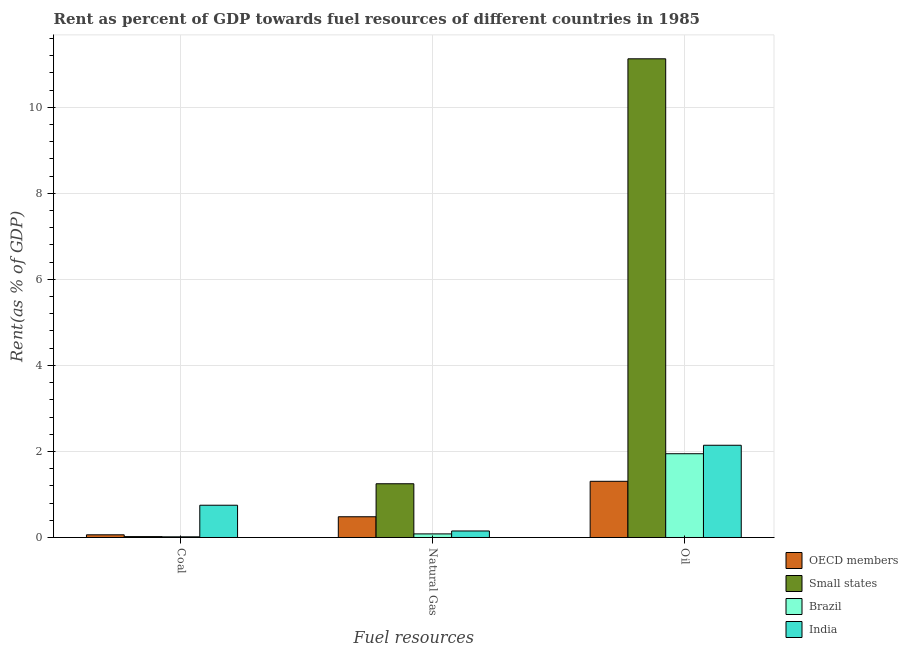How many different coloured bars are there?
Provide a succinct answer. 4. How many groups of bars are there?
Make the answer very short. 3. Are the number of bars per tick equal to the number of legend labels?
Keep it short and to the point. Yes. How many bars are there on the 2nd tick from the right?
Make the answer very short. 4. What is the label of the 1st group of bars from the left?
Ensure brevity in your answer.  Coal. What is the rent towards oil in Small states?
Provide a succinct answer. 11.13. Across all countries, what is the maximum rent towards natural gas?
Offer a terse response. 1.25. Across all countries, what is the minimum rent towards natural gas?
Ensure brevity in your answer.  0.08. In which country was the rent towards natural gas maximum?
Keep it short and to the point. Small states. What is the total rent towards natural gas in the graph?
Provide a short and direct response. 1.97. What is the difference between the rent towards oil in Brazil and that in OECD members?
Ensure brevity in your answer.  0.64. What is the difference between the rent towards coal in Brazil and the rent towards natural gas in OECD members?
Provide a short and direct response. -0.47. What is the average rent towards coal per country?
Ensure brevity in your answer.  0.21. What is the difference between the rent towards coal and rent towards natural gas in India?
Keep it short and to the point. 0.6. What is the ratio of the rent towards natural gas in OECD members to that in Brazil?
Make the answer very short. 5.79. Is the rent towards coal in Small states less than that in Brazil?
Your response must be concise. No. What is the difference between the highest and the second highest rent towards natural gas?
Offer a terse response. 0.77. What is the difference between the highest and the lowest rent towards coal?
Ensure brevity in your answer.  0.73. In how many countries, is the rent towards coal greater than the average rent towards coal taken over all countries?
Offer a terse response. 1. Is the sum of the rent towards natural gas in Small states and Brazil greater than the maximum rent towards coal across all countries?
Your answer should be compact. Yes. What does the 3rd bar from the left in Natural Gas represents?
Provide a succinct answer. Brazil. What does the 3rd bar from the right in Coal represents?
Ensure brevity in your answer.  Small states. Are all the bars in the graph horizontal?
Keep it short and to the point. No. How many countries are there in the graph?
Keep it short and to the point. 4. Are the values on the major ticks of Y-axis written in scientific E-notation?
Your response must be concise. No. Does the graph contain any zero values?
Your answer should be compact. No. What is the title of the graph?
Offer a very short reply. Rent as percent of GDP towards fuel resources of different countries in 1985. What is the label or title of the X-axis?
Give a very brief answer. Fuel resources. What is the label or title of the Y-axis?
Keep it short and to the point. Rent(as % of GDP). What is the Rent(as % of GDP) of OECD members in Coal?
Your answer should be very brief. 0.06. What is the Rent(as % of GDP) in Small states in Coal?
Provide a succinct answer. 0.02. What is the Rent(as % of GDP) of Brazil in Coal?
Give a very brief answer. 0.02. What is the Rent(as % of GDP) in India in Coal?
Make the answer very short. 0.75. What is the Rent(as % of GDP) in OECD members in Natural Gas?
Make the answer very short. 0.48. What is the Rent(as % of GDP) of Small states in Natural Gas?
Offer a very short reply. 1.25. What is the Rent(as % of GDP) of Brazil in Natural Gas?
Provide a succinct answer. 0.08. What is the Rent(as % of GDP) in India in Natural Gas?
Provide a short and direct response. 0.15. What is the Rent(as % of GDP) of OECD members in Oil?
Your answer should be compact. 1.31. What is the Rent(as % of GDP) in Small states in Oil?
Ensure brevity in your answer.  11.13. What is the Rent(as % of GDP) of Brazil in Oil?
Keep it short and to the point. 1.95. What is the Rent(as % of GDP) in India in Oil?
Ensure brevity in your answer.  2.14. Across all Fuel resources, what is the maximum Rent(as % of GDP) in OECD members?
Your response must be concise. 1.31. Across all Fuel resources, what is the maximum Rent(as % of GDP) in Small states?
Offer a terse response. 11.13. Across all Fuel resources, what is the maximum Rent(as % of GDP) in Brazil?
Your response must be concise. 1.95. Across all Fuel resources, what is the maximum Rent(as % of GDP) in India?
Provide a succinct answer. 2.14. Across all Fuel resources, what is the minimum Rent(as % of GDP) of OECD members?
Provide a short and direct response. 0.06. Across all Fuel resources, what is the minimum Rent(as % of GDP) of Small states?
Make the answer very short. 0.02. Across all Fuel resources, what is the minimum Rent(as % of GDP) of Brazil?
Your response must be concise. 0.02. Across all Fuel resources, what is the minimum Rent(as % of GDP) of India?
Your answer should be very brief. 0.15. What is the total Rent(as % of GDP) in OECD members in the graph?
Offer a terse response. 1.85. What is the total Rent(as % of GDP) of Small states in the graph?
Keep it short and to the point. 12.4. What is the total Rent(as % of GDP) of Brazil in the graph?
Offer a very short reply. 2.05. What is the total Rent(as % of GDP) of India in the graph?
Keep it short and to the point. 3.05. What is the difference between the Rent(as % of GDP) in OECD members in Coal and that in Natural Gas?
Provide a short and direct response. -0.42. What is the difference between the Rent(as % of GDP) in Small states in Coal and that in Natural Gas?
Your answer should be compact. -1.23. What is the difference between the Rent(as % of GDP) in Brazil in Coal and that in Natural Gas?
Provide a short and direct response. -0.07. What is the difference between the Rent(as % of GDP) in India in Coal and that in Natural Gas?
Your answer should be very brief. 0.6. What is the difference between the Rent(as % of GDP) of OECD members in Coal and that in Oil?
Your answer should be compact. -1.24. What is the difference between the Rent(as % of GDP) in Small states in Coal and that in Oil?
Make the answer very short. -11.11. What is the difference between the Rent(as % of GDP) in Brazil in Coal and that in Oil?
Your response must be concise. -1.93. What is the difference between the Rent(as % of GDP) of India in Coal and that in Oil?
Your answer should be compact. -1.39. What is the difference between the Rent(as % of GDP) of OECD members in Natural Gas and that in Oil?
Offer a terse response. -0.82. What is the difference between the Rent(as % of GDP) of Small states in Natural Gas and that in Oil?
Provide a succinct answer. -9.88. What is the difference between the Rent(as % of GDP) of Brazil in Natural Gas and that in Oil?
Make the answer very short. -1.86. What is the difference between the Rent(as % of GDP) in India in Natural Gas and that in Oil?
Ensure brevity in your answer.  -1.99. What is the difference between the Rent(as % of GDP) of OECD members in Coal and the Rent(as % of GDP) of Small states in Natural Gas?
Provide a succinct answer. -1.19. What is the difference between the Rent(as % of GDP) in OECD members in Coal and the Rent(as % of GDP) in Brazil in Natural Gas?
Keep it short and to the point. -0.02. What is the difference between the Rent(as % of GDP) in OECD members in Coal and the Rent(as % of GDP) in India in Natural Gas?
Ensure brevity in your answer.  -0.09. What is the difference between the Rent(as % of GDP) in Small states in Coal and the Rent(as % of GDP) in Brazil in Natural Gas?
Ensure brevity in your answer.  -0.06. What is the difference between the Rent(as % of GDP) in Small states in Coal and the Rent(as % of GDP) in India in Natural Gas?
Give a very brief answer. -0.13. What is the difference between the Rent(as % of GDP) of Brazil in Coal and the Rent(as % of GDP) of India in Natural Gas?
Your response must be concise. -0.14. What is the difference between the Rent(as % of GDP) in OECD members in Coal and the Rent(as % of GDP) in Small states in Oil?
Offer a very short reply. -11.06. What is the difference between the Rent(as % of GDP) in OECD members in Coal and the Rent(as % of GDP) in Brazil in Oil?
Your answer should be compact. -1.88. What is the difference between the Rent(as % of GDP) of OECD members in Coal and the Rent(as % of GDP) of India in Oil?
Offer a terse response. -2.08. What is the difference between the Rent(as % of GDP) in Small states in Coal and the Rent(as % of GDP) in Brazil in Oil?
Give a very brief answer. -1.93. What is the difference between the Rent(as % of GDP) in Small states in Coal and the Rent(as % of GDP) in India in Oil?
Your response must be concise. -2.12. What is the difference between the Rent(as % of GDP) of Brazil in Coal and the Rent(as % of GDP) of India in Oil?
Give a very brief answer. -2.13. What is the difference between the Rent(as % of GDP) of OECD members in Natural Gas and the Rent(as % of GDP) of Small states in Oil?
Give a very brief answer. -10.65. What is the difference between the Rent(as % of GDP) in OECD members in Natural Gas and the Rent(as % of GDP) in Brazil in Oil?
Your answer should be compact. -1.47. What is the difference between the Rent(as % of GDP) in OECD members in Natural Gas and the Rent(as % of GDP) in India in Oil?
Make the answer very short. -1.66. What is the difference between the Rent(as % of GDP) in Small states in Natural Gas and the Rent(as % of GDP) in Brazil in Oil?
Your response must be concise. -0.7. What is the difference between the Rent(as % of GDP) of Small states in Natural Gas and the Rent(as % of GDP) of India in Oil?
Provide a succinct answer. -0.9. What is the difference between the Rent(as % of GDP) in Brazil in Natural Gas and the Rent(as % of GDP) in India in Oil?
Ensure brevity in your answer.  -2.06. What is the average Rent(as % of GDP) in OECD members per Fuel resources?
Your response must be concise. 0.62. What is the average Rent(as % of GDP) in Small states per Fuel resources?
Keep it short and to the point. 4.13. What is the average Rent(as % of GDP) of Brazil per Fuel resources?
Ensure brevity in your answer.  0.68. What is the average Rent(as % of GDP) of India per Fuel resources?
Your answer should be very brief. 1.02. What is the difference between the Rent(as % of GDP) of OECD members and Rent(as % of GDP) of Small states in Coal?
Offer a terse response. 0.04. What is the difference between the Rent(as % of GDP) of OECD members and Rent(as % of GDP) of Brazil in Coal?
Provide a short and direct response. 0.05. What is the difference between the Rent(as % of GDP) of OECD members and Rent(as % of GDP) of India in Coal?
Give a very brief answer. -0.69. What is the difference between the Rent(as % of GDP) of Small states and Rent(as % of GDP) of Brazil in Coal?
Make the answer very short. 0. What is the difference between the Rent(as % of GDP) in Small states and Rent(as % of GDP) in India in Coal?
Offer a terse response. -0.73. What is the difference between the Rent(as % of GDP) of Brazil and Rent(as % of GDP) of India in Coal?
Your answer should be compact. -0.73. What is the difference between the Rent(as % of GDP) of OECD members and Rent(as % of GDP) of Small states in Natural Gas?
Give a very brief answer. -0.77. What is the difference between the Rent(as % of GDP) of OECD members and Rent(as % of GDP) of Brazil in Natural Gas?
Make the answer very short. 0.4. What is the difference between the Rent(as % of GDP) of OECD members and Rent(as % of GDP) of India in Natural Gas?
Your answer should be very brief. 0.33. What is the difference between the Rent(as % of GDP) of Small states and Rent(as % of GDP) of Brazil in Natural Gas?
Your response must be concise. 1.17. What is the difference between the Rent(as % of GDP) of Small states and Rent(as % of GDP) of India in Natural Gas?
Provide a succinct answer. 1.1. What is the difference between the Rent(as % of GDP) in Brazil and Rent(as % of GDP) in India in Natural Gas?
Give a very brief answer. -0.07. What is the difference between the Rent(as % of GDP) of OECD members and Rent(as % of GDP) of Small states in Oil?
Your answer should be compact. -9.82. What is the difference between the Rent(as % of GDP) of OECD members and Rent(as % of GDP) of Brazil in Oil?
Offer a very short reply. -0.64. What is the difference between the Rent(as % of GDP) of OECD members and Rent(as % of GDP) of India in Oil?
Your response must be concise. -0.84. What is the difference between the Rent(as % of GDP) in Small states and Rent(as % of GDP) in Brazil in Oil?
Keep it short and to the point. 9.18. What is the difference between the Rent(as % of GDP) in Small states and Rent(as % of GDP) in India in Oil?
Your response must be concise. 8.98. What is the difference between the Rent(as % of GDP) in Brazil and Rent(as % of GDP) in India in Oil?
Provide a short and direct response. -0.2. What is the ratio of the Rent(as % of GDP) in OECD members in Coal to that in Natural Gas?
Your answer should be compact. 0.13. What is the ratio of the Rent(as % of GDP) of Small states in Coal to that in Natural Gas?
Your response must be concise. 0.02. What is the ratio of the Rent(as % of GDP) in Brazil in Coal to that in Natural Gas?
Keep it short and to the point. 0.19. What is the ratio of the Rent(as % of GDP) of India in Coal to that in Natural Gas?
Your answer should be compact. 4.95. What is the ratio of the Rent(as % of GDP) in OECD members in Coal to that in Oil?
Offer a terse response. 0.05. What is the ratio of the Rent(as % of GDP) of Small states in Coal to that in Oil?
Provide a short and direct response. 0. What is the ratio of the Rent(as % of GDP) in Brazil in Coal to that in Oil?
Your answer should be compact. 0.01. What is the ratio of the Rent(as % of GDP) of India in Coal to that in Oil?
Keep it short and to the point. 0.35. What is the ratio of the Rent(as % of GDP) in OECD members in Natural Gas to that in Oil?
Provide a succinct answer. 0.37. What is the ratio of the Rent(as % of GDP) in Small states in Natural Gas to that in Oil?
Keep it short and to the point. 0.11. What is the ratio of the Rent(as % of GDP) in Brazil in Natural Gas to that in Oil?
Provide a short and direct response. 0.04. What is the ratio of the Rent(as % of GDP) of India in Natural Gas to that in Oil?
Provide a succinct answer. 0.07. What is the difference between the highest and the second highest Rent(as % of GDP) of OECD members?
Your answer should be very brief. 0.82. What is the difference between the highest and the second highest Rent(as % of GDP) of Small states?
Keep it short and to the point. 9.88. What is the difference between the highest and the second highest Rent(as % of GDP) of Brazil?
Provide a succinct answer. 1.86. What is the difference between the highest and the second highest Rent(as % of GDP) in India?
Offer a very short reply. 1.39. What is the difference between the highest and the lowest Rent(as % of GDP) of OECD members?
Your response must be concise. 1.24. What is the difference between the highest and the lowest Rent(as % of GDP) of Small states?
Ensure brevity in your answer.  11.11. What is the difference between the highest and the lowest Rent(as % of GDP) of Brazil?
Make the answer very short. 1.93. What is the difference between the highest and the lowest Rent(as % of GDP) of India?
Give a very brief answer. 1.99. 